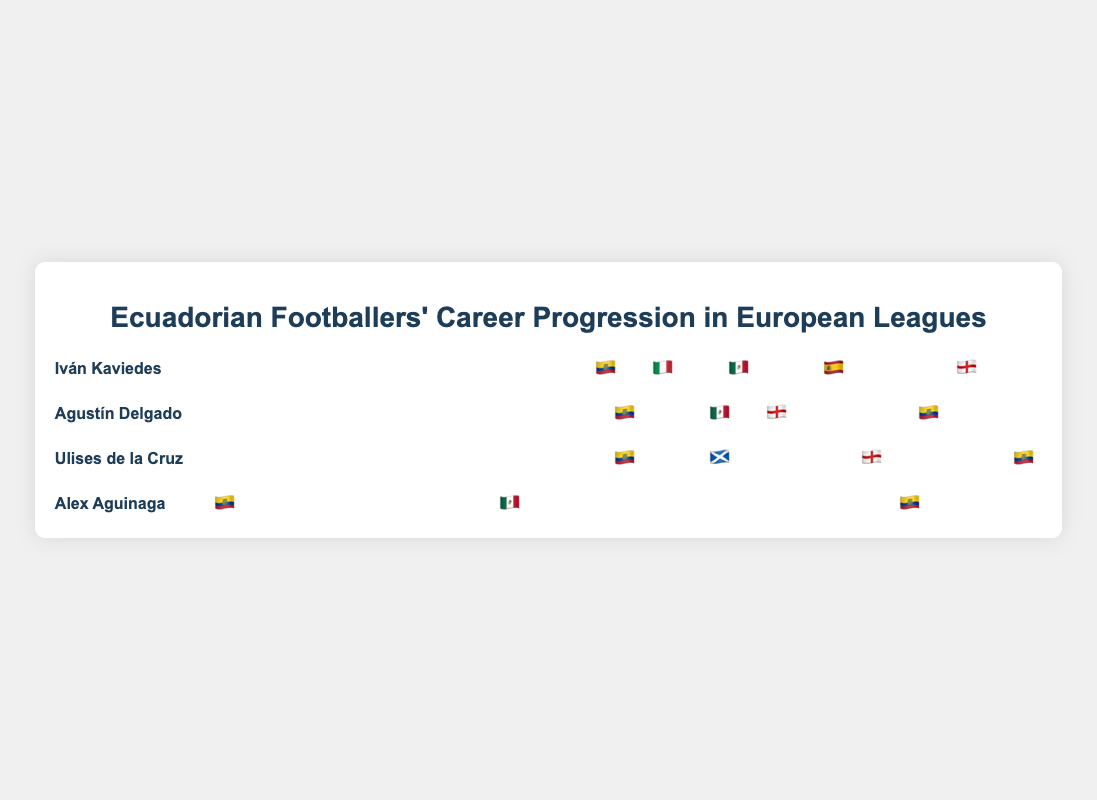What league did Iván Kaviedes play in during 1999? Refer to Kaviedes' career path in 1999; the league is represented by Italy's flag.
Answer: 🇮🇹 Italian Serie A Which player had a career stint in the Scottish Premiership, and in what year? Look for the Scottish Premiership flag (🏴) and identify the player and year from the timeline.
Answer: Ulises de la Cruz in 2001 How many different leagues did Agustín Delgado play in? Count the distinct flags in Delgado's career progression.
Answer: Three Compare Iván Kaviedes and Ulises de la Cruz: who first played in the English Premier League? Find the year each player appeared in the English Premier League and compare them.
Answer: Ulises de la Cruz in 2002 What years did Alex Aguinaga play in the Ecuadorian Serie A? Check Aguinaga's timeline for the years associated with the Ecuadorian Serie A flag.
Answer: 1988, 2003 Which player returned to the Ecuadorian Serie A after playing in Europe? Find the player with a career path that includes returning to the Ecuadorian Serie A after a European league.
Answer: Agustín Delgado (2004) What is the first league Iván Kaviedes played in after the Ecuadorian Serie A? Look at the next league in Kaviedes' timeline after the Ecuadorian Serie A in 1998.
Answer: 🇮🇹 Italian Serie A Out of the four players, who had the most career transitions visible in the chart? Count the career changes or distinct league stints for each player.
Answer: Iván Kaviedes Compare the number of leagues played in Europe by Ulises de la Cruz and Agustín Delgado. Which player played in more European leagues? Determine the number of European leagues each player was in and compare them.
Answer: Ulises de la Cruz Which player played in the Mexican Liga MX and the Spanish La Liga? Identify the player with stints in leagues represented by both the Mexican and Spanish flags.
Answer: Iván Kaviedes 